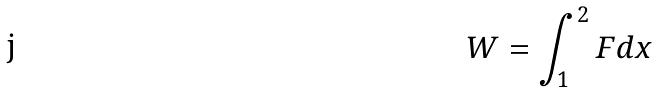Convert formula to latex. <formula><loc_0><loc_0><loc_500><loc_500>W = \int _ { 1 } ^ { 2 } F d x</formula> 